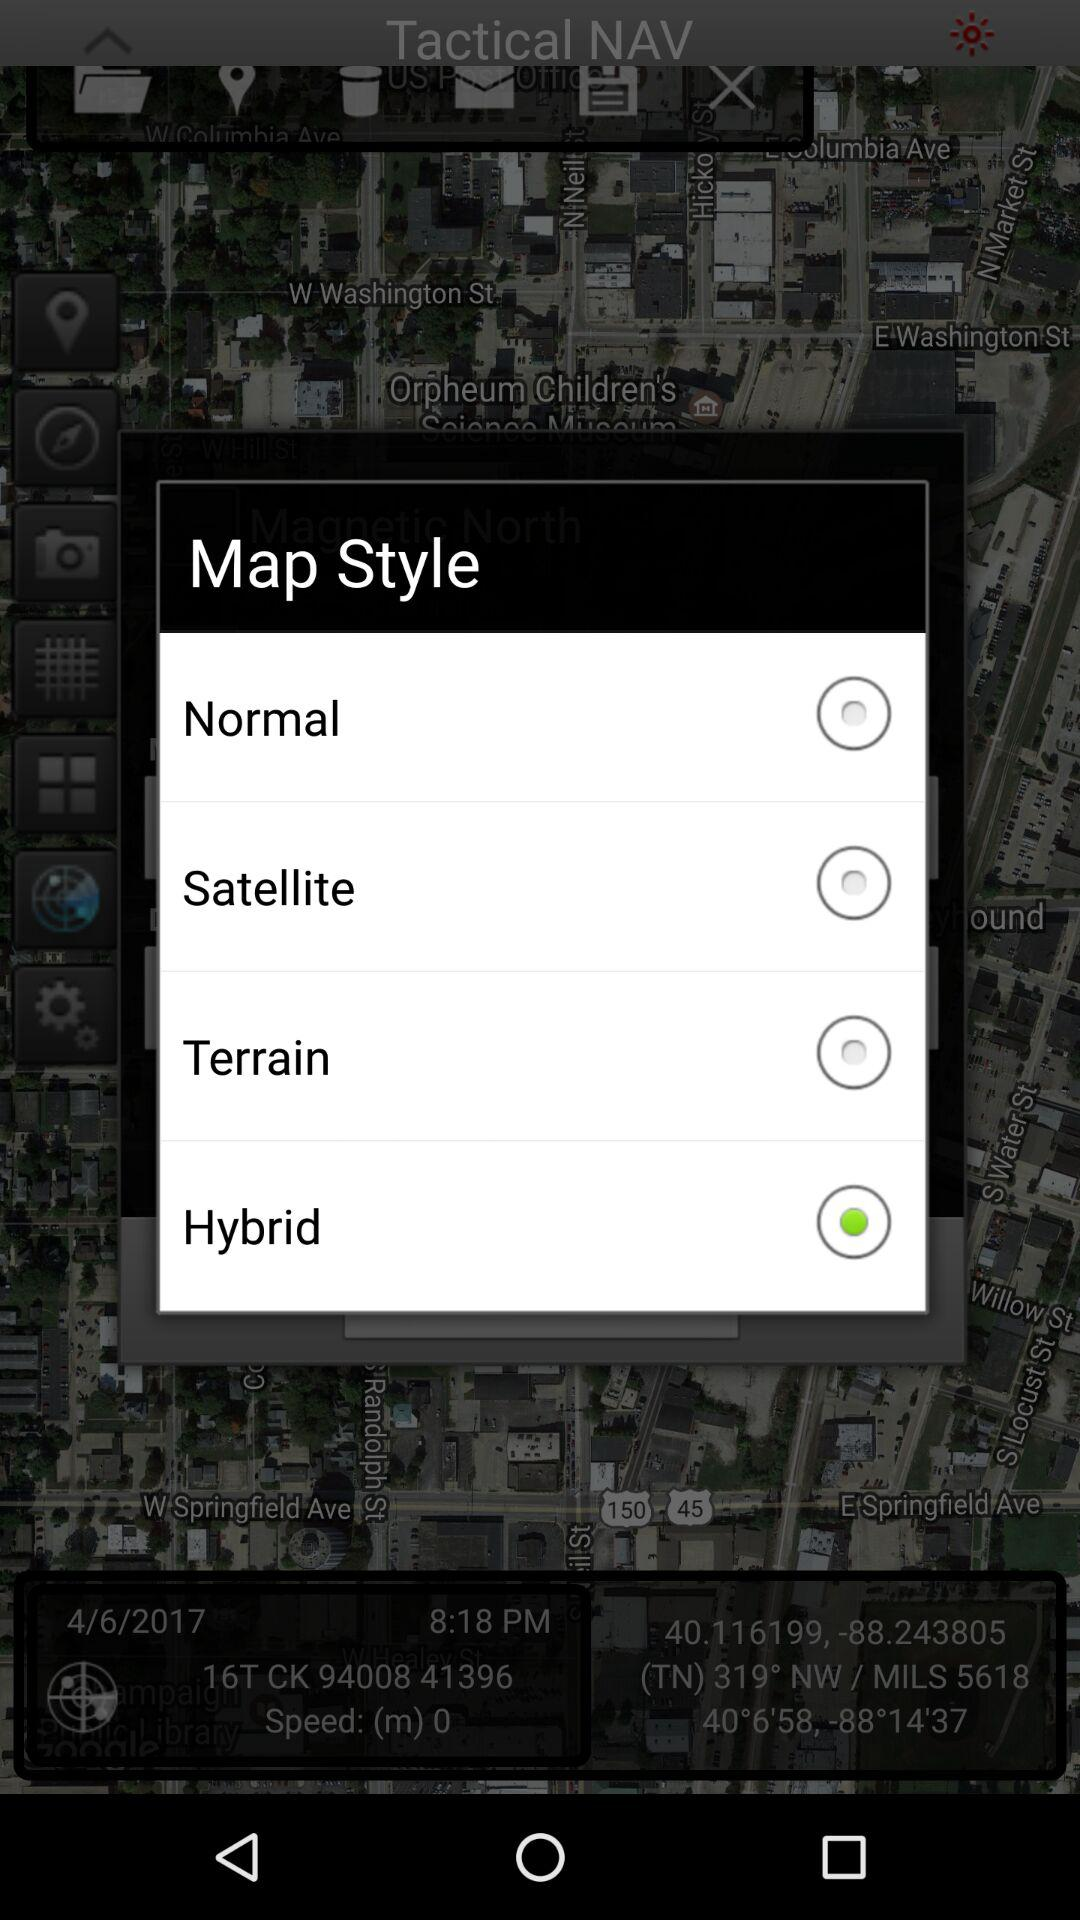Which map style is selected? The selected map style is hybrid. 